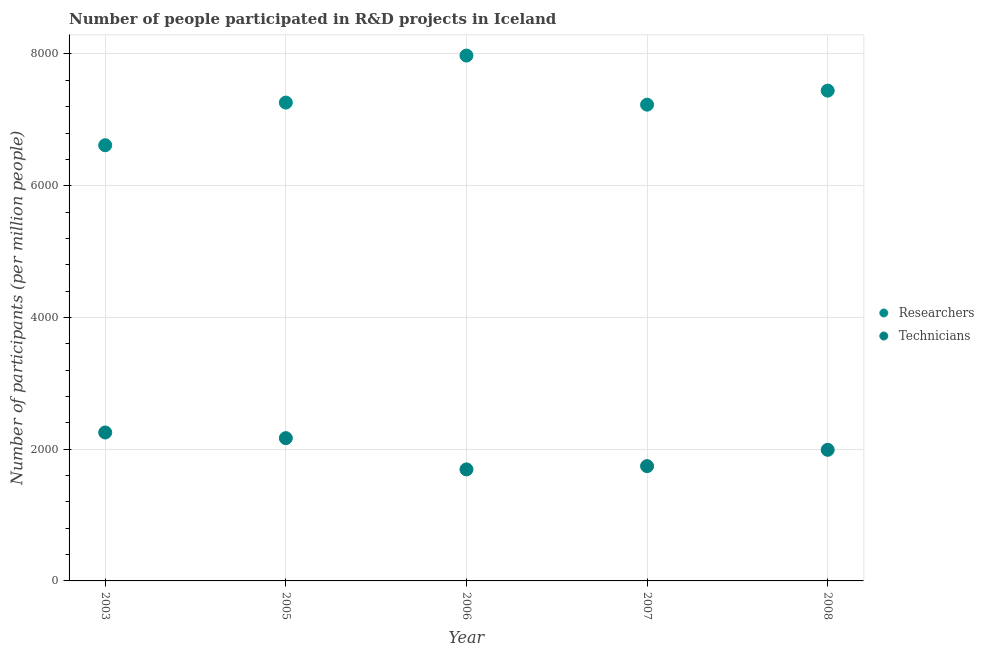How many different coloured dotlines are there?
Your answer should be compact. 2. Is the number of dotlines equal to the number of legend labels?
Provide a short and direct response. Yes. What is the number of researchers in 2008?
Your response must be concise. 7443.32. Across all years, what is the maximum number of technicians?
Offer a terse response. 2253.45. Across all years, what is the minimum number of technicians?
Your answer should be compact. 1693.11. What is the total number of researchers in the graph?
Your answer should be very brief. 3.65e+04. What is the difference between the number of technicians in 2006 and that in 2008?
Offer a terse response. -297.12. What is the difference between the number of researchers in 2006 and the number of technicians in 2005?
Provide a short and direct response. 5808.06. What is the average number of technicians per year?
Offer a very short reply. 1969.46. In the year 2005, what is the difference between the number of technicians and number of researchers?
Keep it short and to the point. -5094.23. What is the ratio of the number of technicians in 2003 to that in 2005?
Your answer should be very brief. 1.04. Is the number of researchers in 2007 less than that in 2008?
Keep it short and to the point. Yes. Is the difference between the number of researchers in 2003 and 2005 greater than the difference between the number of technicians in 2003 and 2005?
Make the answer very short. No. What is the difference between the highest and the second highest number of researchers?
Your answer should be very brief. 532.3. What is the difference between the highest and the lowest number of researchers?
Provide a short and direct response. 1361.26. In how many years, is the number of technicians greater than the average number of technicians taken over all years?
Provide a short and direct response. 3. Does the number of researchers monotonically increase over the years?
Your response must be concise. No. Is the number of technicians strictly less than the number of researchers over the years?
Your response must be concise. Yes. How many years are there in the graph?
Offer a terse response. 5. What is the difference between two consecutive major ticks on the Y-axis?
Offer a very short reply. 2000. Does the graph contain any zero values?
Provide a succinct answer. No. Where does the legend appear in the graph?
Provide a short and direct response. Center right. What is the title of the graph?
Your response must be concise. Number of people participated in R&D projects in Iceland. Does "Quasi money growth" appear as one of the legend labels in the graph?
Ensure brevity in your answer.  No. What is the label or title of the X-axis?
Your answer should be compact. Year. What is the label or title of the Y-axis?
Provide a succinct answer. Number of participants (per million people). What is the Number of participants (per million people) of Researchers in 2003?
Your answer should be compact. 6614.36. What is the Number of participants (per million people) of Technicians in 2003?
Your answer should be compact. 2253.45. What is the Number of participants (per million people) of Researchers in 2005?
Your answer should be very brief. 7261.79. What is the Number of participants (per million people) in Technicians in 2005?
Give a very brief answer. 2167.56. What is the Number of participants (per million people) in Researchers in 2006?
Provide a short and direct response. 7975.62. What is the Number of participants (per million people) of Technicians in 2006?
Ensure brevity in your answer.  1693.11. What is the Number of participants (per million people) of Researchers in 2007?
Offer a very short reply. 7230.49. What is the Number of participants (per million people) in Technicians in 2007?
Your answer should be very brief. 1742.94. What is the Number of participants (per million people) in Researchers in 2008?
Offer a very short reply. 7443.32. What is the Number of participants (per million people) in Technicians in 2008?
Your response must be concise. 1990.23. Across all years, what is the maximum Number of participants (per million people) in Researchers?
Your answer should be compact. 7975.62. Across all years, what is the maximum Number of participants (per million people) of Technicians?
Give a very brief answer. 2253.45. Across all years, what is the minimum Number of participants (per million people) in Researchers?
Make the answer very short. 6614.36. Across all years, what is the minimum Number of participants (per million people) of Technicians?
Give a very brief answer. 1693.11. What is the total Number of participants (per million people) of Researchers in the graph?
Offer a very short reply. 3.65e+04. What is the total Number of participants (per million people) of Technicians in the graph?
Offer a very short reply. 9847.28. What is the difference between the Number of participants (per million people) in Researchers in 2003 and that in 2005?
Make the answer very short. -647.43. What is the difference between the Number of participants (per million people) in Technicians in 2003 and that in 2005?
Make the answer very short. 85.89. What is the difference between the Number of participants (per million people) in Researchers in 2003 and that in 2006?
Offer a very short reply. -1361.26. What is the difference between the Number of participants (per million people) of Technicians in 2003 and that in 2006?
Provide a succinct answer. 560.34. What is the difference between the Number of participants (per million people) of Researchers in 2003 and that in 2007?
Offer a terse response. -616.13. What is the difference between the Number of participants (per million people) in Technicians in 2003 and that in 2007?
Offer a terse response. 510.51. What is the difference between the Number of participants (per million people) of Researchers in 2003 and that in 2008?
Your answer should be compact. -828.96. What is the difference between the Number of participants (per million people) of Technicians in 2003 and that in 2008?
Give a very brief answer. 263.22. What is the difference between the Number of participants (per million people) of Researchers in 2005 and that in 2006?
Keep it short and to the point. -713.83. What is the difference between the Number of participants (per million people) in Technicians in 2005 and that in 2006?
Give a very brief answer. 474.45. What is the difference between the Number of participants (per million people) of Researchers in 2005 and that in 2007?
Ensure brevity in your answer.  31.3. What is the difference between the Number of participants (per million people) of Technicians in 2005 and that in 2007?
Provide a short and direct response. 424.61. What is the difference between the Number of participants (per million people) in Researchers in 2005 and that in 2008?
Offer a terse response. -181.53. What is the difference between the Number of participants (per million people) in Technicians in 2005 and that in 2008?
Your answer should be very brief. 177.33. What is the difference between the Number of participants (per million people) in Researchers in 2006 and that in 2007?
Make the answer very short. 745.13. What is the difference between the Number of participants (per million people) of Technicians in 2006 and that in 2007?
Offer a terse response. -49.84. What is the difference between the Number of participants (per million people) of Researchers in 2006 and that in 2008?
Your response must be concise. 532.3. What is the difference between the Number of participants (per million people) of Technicians in 2006 and that in 2008?
Provide a short and direct response. -297.12. What is the difference between the Number of participants (per million people) in Researchers in 2007 and that in 2008?
Your answer should be compact. -212.83. What is the difference between the Number of participants (per million people) of Technicians in 2007 and that in 2008?
Keep it short and to the point. -247.28. What is the difference between the Number of participants (per million people) of Researchers in 2003 and the Number of participants (per million people) of Technicians in 2005?
Your answer should be very brief. 4446.8. What is the difference between the Number of participants (per million people) of Researchers in 2003 and the Number of participants (per million people) of Technicians in 2006?
Keep it short and to the point. 4921.25. What is the difference between the Number of participants (per million people) in Researchers in 2003 and the Number of participants (per million people) in Technicians in 2007?
Your answer should be very brief. 4871.42. What is the difference between the Number of participants (per million people) of Researchers in 2003 and the Number of participants (per million people) of Technicians in 2008?
Provide a succinct answer. 4624.13. What is the difference between the Number of participants (per million people) in Researchers in 2005 and the Number of participants (per million people) in Technicians in 2006?
Your answer should be very brief. 5568.68. What is the difference between the Number of participants (per million people) of Researchers in 2005 and the Number of participants (per million people) of Technicians in 2007?
Your answer should be compact. 5518.85. What is the difference between the Number of participants (per million people) of Researchers in 2005 and the Number of participants (per million people) of Technicians in 2008?
Offer a very short reply. 5271.56. What is the difference between the Number of participants (per million people) of Researchers in 2006 and the Number of participants (per million people) of Technicians in 2007?
Ensure brevity in your answer.  6232.68. What is the difference between the Number of participants (per million people) of Researchers in 2006 and the Number of participants (per million people) of Technicians in 2008?
Your response must be concise. 5985.39. What is the difference between the Number of participants (per million people) in Researchers in 2007 and the Number of participants (per million people) in Technicians in 2008?
Ensure brevity in your answer.  5240.26. What is the average Number of participants (per million people) in Researchers per year?
Your answer should be compact. 7305.11. What is the average Number of participants (per million people) of Technicians per year?
Make the answer very short. 1969.46. In the year 2003, what is the difference between the Number of participants (per million people) in Researchers and Number of participants (per million people) in Technicians?
Offer a very short reply. 4360.91. In the year 2005, what is the difference between the Number of participants (per million people) of Researchers and Number of participants (per million people) of Technicians?
Provide a succinct answer. 5094.23. In the year 2006, what is the difference between the Number of participants (per million people) of Researchers and Number of participants (per million people) of Technicians?
Offer a terse response. 6282.51. In the year 2007, what is the difference between the Number of participants (per million people) in Researchers and Number of participants (per million people) in Technicians?
Your response must be concise. 5487.55. In the year 2008, what is the difference between the Number of participants (per million people) of Researchers and Number of participants (per million people) of Technicians?
Ensure brevity in your answer.  5453.09. What is the ratio of the Number of participants (per million people) in Researchers in 2003 to that in 2005?
Make the answer very short. 0.91. What is the ratio of the Number of participants (per million people) in Technicians in 2003 to that in 2005?
Provide a succinct answer. 1.04. What is the ratio of the Number of participants (per million people) of Researchers in 2003 to that in 2006?
Your response must be concise. 0.83. What is the ratio of the Number of participants (per million people) in Technicians in 2003 to that in 2006?
Make the answer very short. 1.33. What is the ratio of the Number of participants (per million people) of Researchers in 2003 to that in 2007?
Ensure brevity in your answer.  0.91. What is the ratio of the Number of participants (per million people) in Technicians in 2003 to that in 2007?
Your answer should be compact. 1.29. What is the ratio of the Number of participants (per million people) of Researchers in 2003 to that in 2008?
Offer a very short reply. 0.89. What is the ratio of the Number of participants (per million people) of Technicians in 2003 to that in 2008?
Provide a succinct answer. 1.13. What is the ratio of the Number of participants (per million people) of Researchers in 2005 to that in 2006?
Keep it short and to the point. 0.91. What is the ratio of the Number of participants (per million people) in Technicians in 2005 to that in 2006?
Your answer should be compact. 1.28. What is the ratio of the Number of participants (per million people) of Technicians in 2005 to that in 2007?
Your answer should be very brief. 1.24. What is the ratio of the Number of participants (per million people) in Researchers in 2005 to that in 2008?
Your answer should be compact. 0.98. What is the ratio of the Number of participants (per million people) in Technicians in 2005 to that in 2008?
Provide a succinct answer. 1.09. What is the ratio of the Number of participants (per million people) of Researchers in 2006 to that in 2007?
Ensure brevity in your answer.  1.1. What is the ratio of the Number of participants (per million people) in Technicians in 2006 to that in 2007?
Offer a very short reply. 0.97. What is the ratio of the Number of participants (per million people) in Researchers in 2006 to that in 2008?
Make the answer very short. 1.07. What is the ratio of the Number of participants (per million people) of Technicians in 2006 to that in 2008?
Your response must be concise. 0.85. What is the ratio of the Number of participants (per million people) in Researchers in 2007 to that in 2008?
Your response must be concise. 0.97. What is the ratio of the Number of participants (per million people) in Technicians in 2007 to that in 2008?
Provide a succinct answer. 0.88. What is the difference between the highest and the second highest Number of participants (per million people) of Researchers?
Offer a terse response. 532.3. What is the difference between the highest and the second highest Number of participants (per million people) in Technicians?
Make the answer very short. 85.89. What is the difference between the highest and the lowest Number of participants (per million people) in Researchers?
Ensure brevity in your answer.  1361.26. What is the difference between the highest and the lowest Number of participants (per million people) of Technicians?
Ensure brevity in your answer.  560.34. 